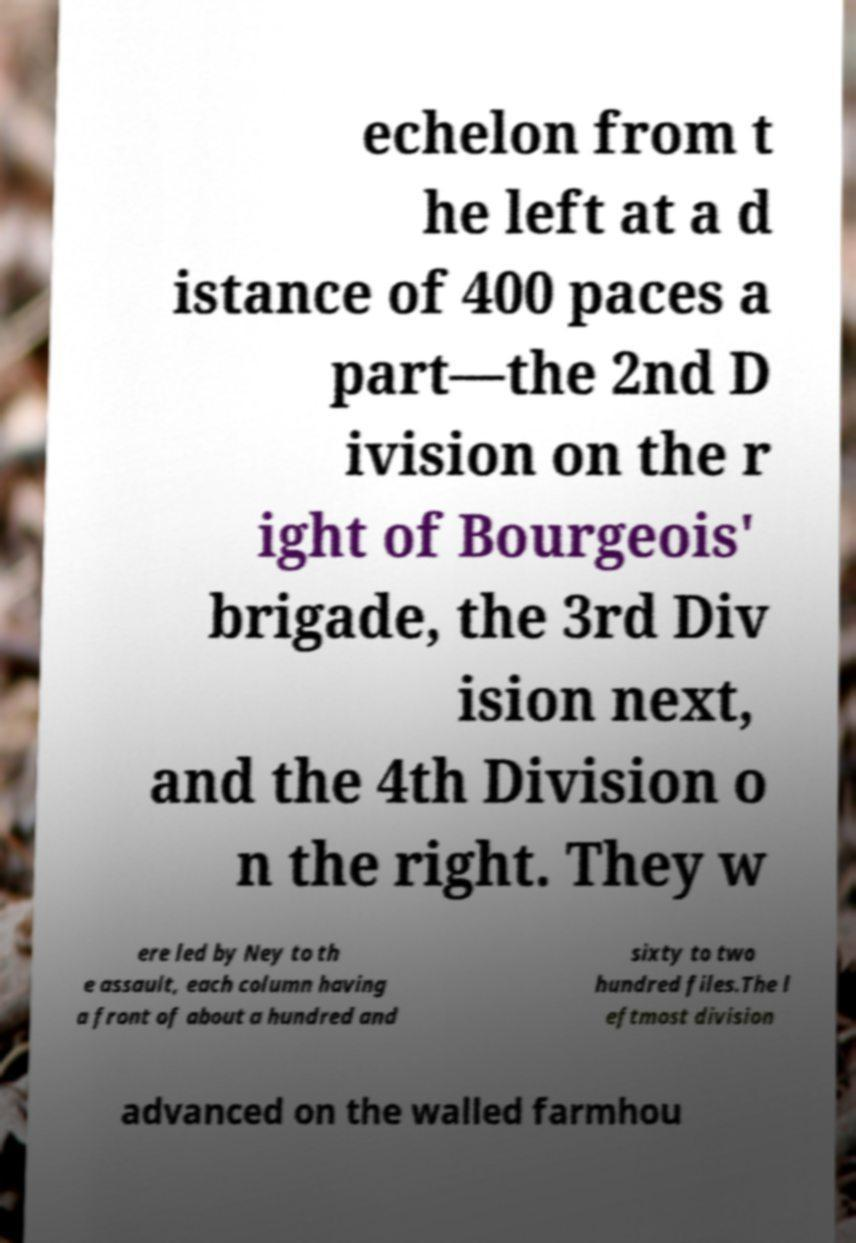I need the written content from this picture converted into text. Can you do that? echelon from t he left at a d istance of 400 paces a part—the 2nd D ivision on the r ight of Bourgeois' brigade, the 3rd Div ision next, and the 4th Division o n the right. They w ere led by Ney to th e assault, each column having a front of about a hundred and sixty to two hundred files.The l eftmost division advanced on the walled farmhou 